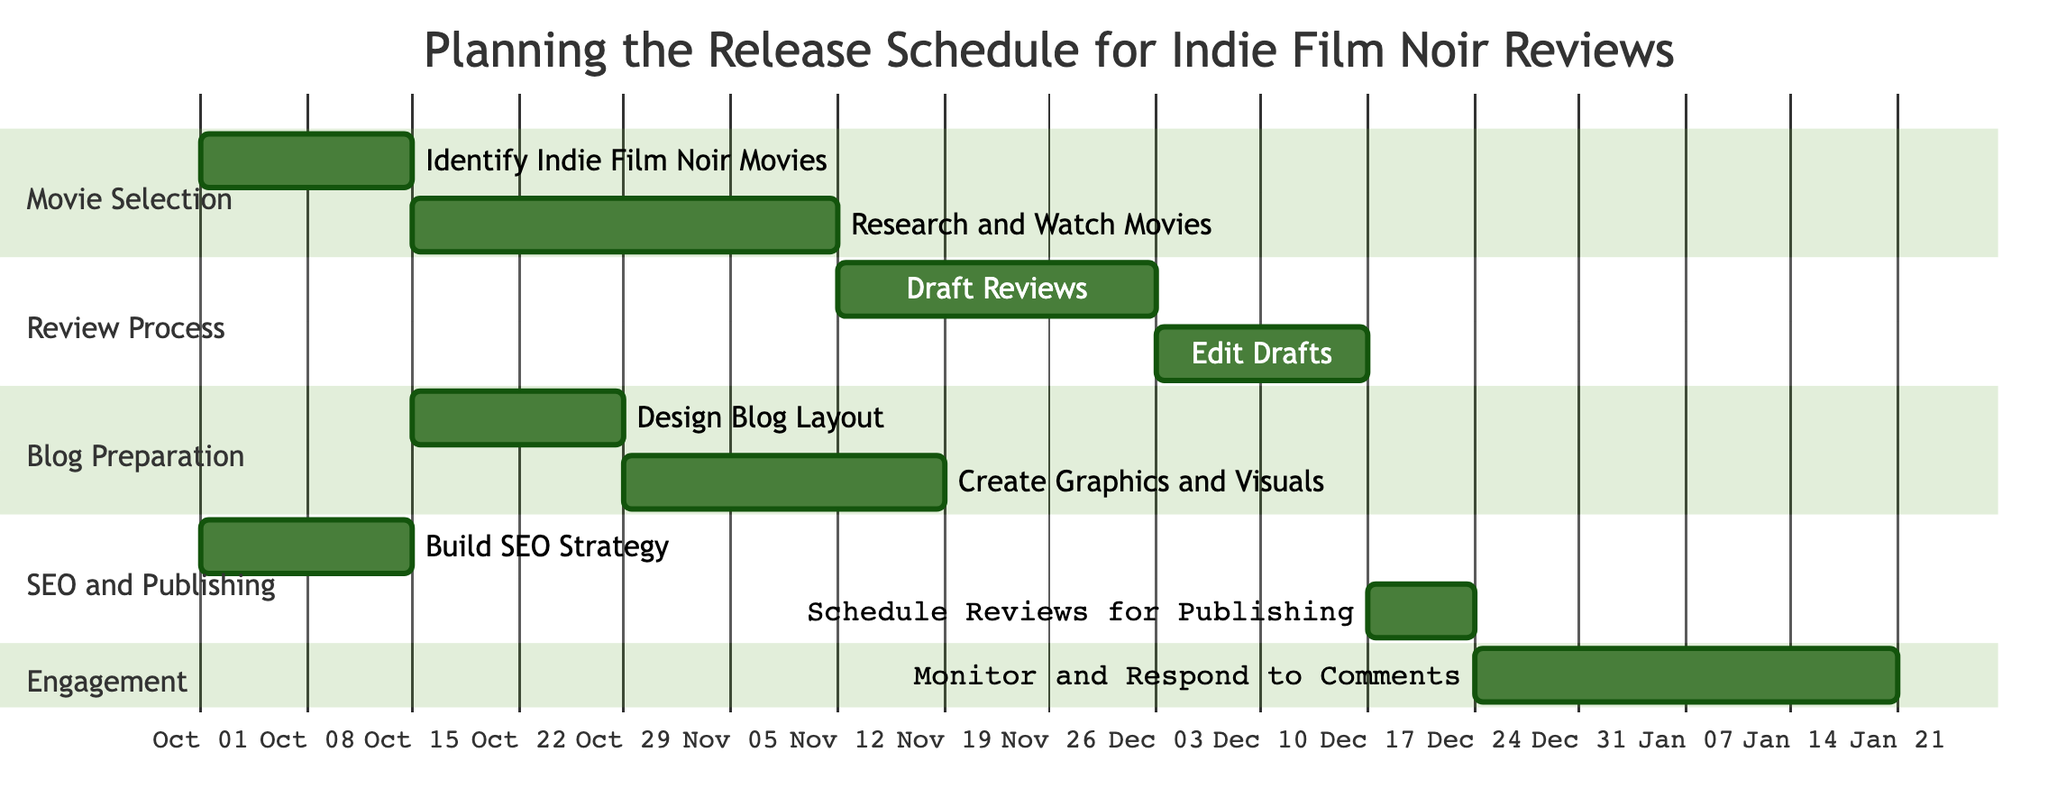What is the duration of the "Research and Watch Movies" task? The duration for "Research and Watch Movies" is specified in the diagram as four weeks.
Answer: 4 weeks How many tasks are dependent on "Edit Drafts"? The diagram shows that there is only one task, "Schedule Reviews for Publishing," that depends on "Edit Drafts."
Answer: 1 task When does the "Create Graphics and Visuals" task start? By following the timeline in the diagram, "Create Graphics and Visuals" starts after the "Design Blog Layout," which begins on November 1, 2023.
Answer: November 1, 2023 What is the total duration for the "Monitor and Respond to Comments" task? The total duration for "Monitor and Respond to Comments" is specified in the diagram as four weeks.
Answer: 4 weeks Which task starts before "Draft Reviews"? "Research and Watch Movies" starts before "Draft Reviews," directly preceding it in the workflow as it is represented after the first task, "Identify Indie Film Noir Movies."
Answer: Research and Watch Movies How many sections are there in the Gantt Chart? The Gantt Chart has four sections titled Movie Selection, Review Process, Blog Preparation, and SEO and Publishing. Counting these, there are four sections in total.
Answer: 4 sections What is the last task scheduled in the timeline? The last task scheduled in the timeline is "Monitor and Respond to Comments," which starts on January 1, 2024, after "Schedule Reviews for Publishing."
Answer: Monitor and Respond to Comments How long is the "Draft Reviews" process? The "Draft Reviews" process lasts for three weeks as indicated in the duration specified in the diagram.
Answer: 3 weeks What task begins on the same date as "Build SEO Strategy"? The "Identify Indie Film Noir Movies" task also begins on the same date, October 1, 2023, right before "Build SEO Strategy."
Answer: Identify Indie Film Noir Movies 